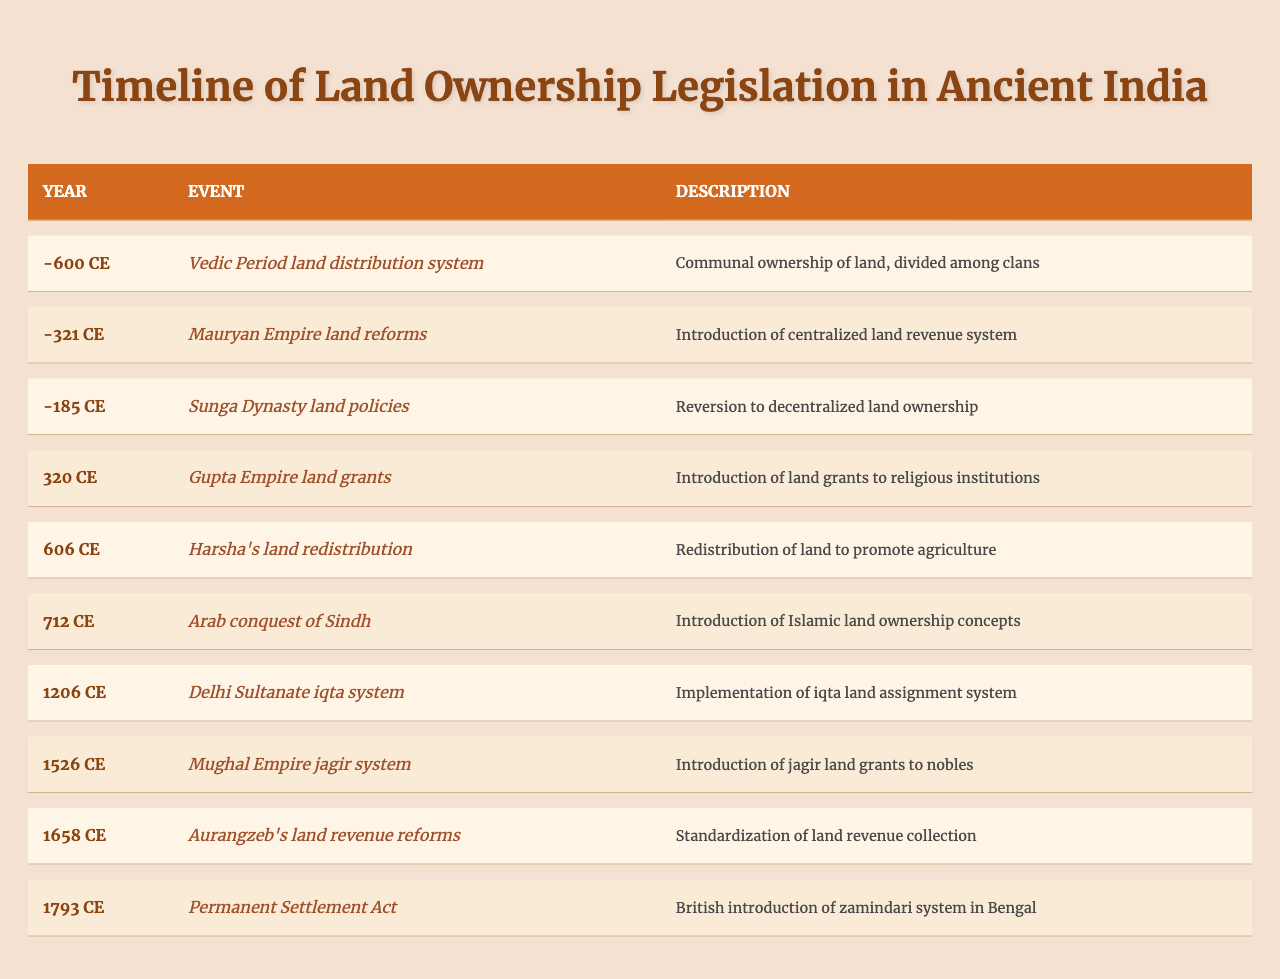What year did the Vedic Period land distribution system occur? According to the table, the Vedic Period land distribution system happened in the year -600.
Answer: -600 What event introduced the centralized land revenue system? The Mauryan Empire land reforms event, which introduced the centralized land revenue system, occurred in the year -321.
Answer: Mauryan Empire land reforms In which year were land grants introduced to religious institutions? The table states that land grants to religious institutions were introduced in the year 320.
Answer: 320 What was the main outcome of Harsha's land redistribution in 606? The outcome of Harsha's land redistribution in 606 was the redistribution of land to promote agriculture, as described in the table.
Answer: Redistribution to promote agriculture Which event occurred first: the Mughal Empire's jagir system or Aurangzeb's land revenue reforms? By assessing the years in the table, the Mughal Empire's jagir system occurred in 1526, while Aurangzeb's land revenue reforms happened in 1658. Therefore, the jagir system occurred first.
Answer: Mughal Empire's jagir system How many events related to land ownership legislation occurred before 600 CE? By counting the events in the table that occurred before 600 CE, we find 6 events: Vedic Period, Mauryan Empire, Sunga Dynasty, Gupta Empire, Harsha's redistribution, and Arab conquest. Hence, there are 6 events.
Answer: 6 Was there any change in land ownership concepts during the Arab conquest of Sindh? The table indicates that the Arab conquest of Sindh introduced Islamic land ownership concepts, confirming that a change did indeed occur.
Answer: Yes What difference in years exists between the Permanent Settlement Act and the Delhi Sultanate iqta system? The Permanent Settlement Act occurred in 1793, and the Delhi Sultanate iqta system occurred in 1206. The difference is 1793 - 1206 = 587 years.
Answer: 587 years Which two events involved religious institutions and what were their years? The two events that involved religious institutions were the Gupta Empire land grants in 320 and the later influence of Islamic concepts in the Arab conquest of Sindh in 712.
Answer: Gupta Empire (320) and Arab conquest (712) Considering all events, what is the earliest recorded event related to land ownership? The earliest recorded event related to land ownership is the Vedic Period land distribution system in -600. The table confirms this as the first entry.
Answer: -600 How did land ownership change from the Sunga Dynasty to the Gupta Empire? The Sunga Dynasty reversed to decentralized land ownership around -185, while the Gupta Empire introduced land grants to religious institutions in 320, marking a shift towards recognizing institutional ownership.
Answer: Shift from decentralized to institutional ownership 